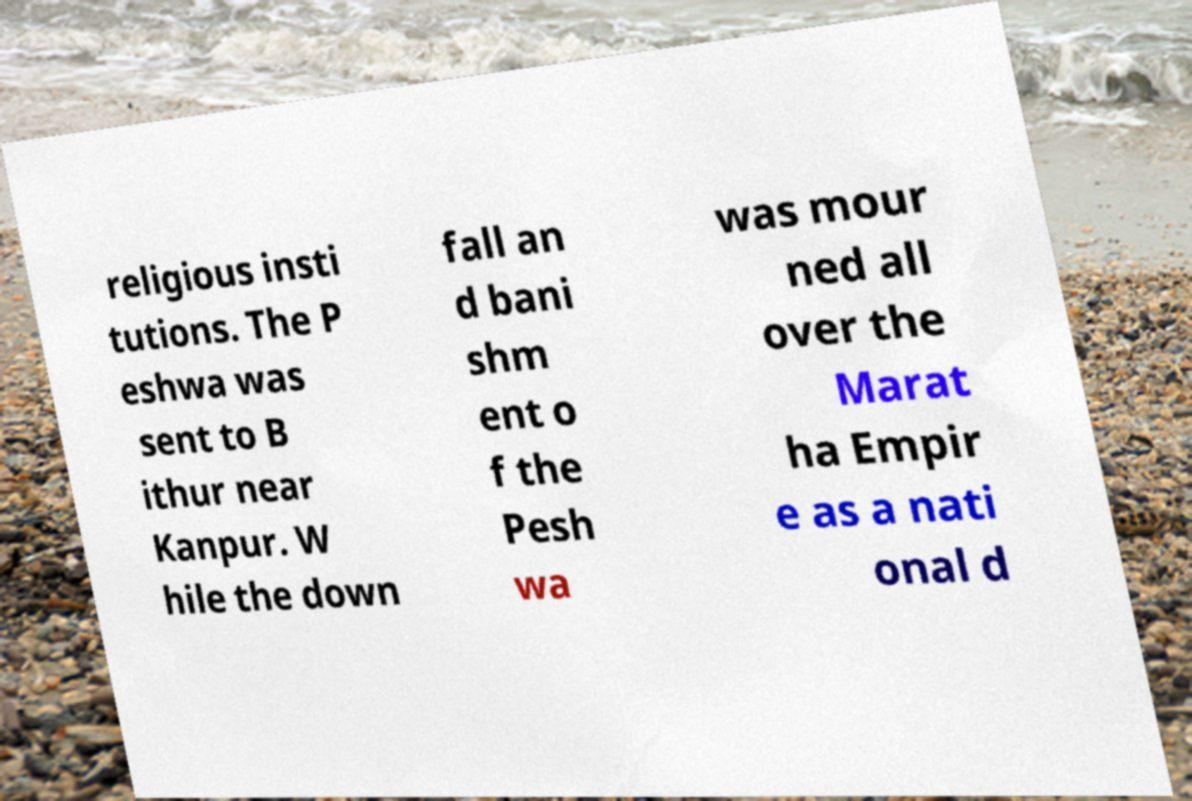Could you assist in decoding the text presented in this image and type it out clearly? religious insti tutions. The P eshwa was sent to B ithur near Kanpur. W hile the down fall an d bani shm ent o f the Pesh wa was mour ned all over the Marat ha Empir e as a nati onal d 